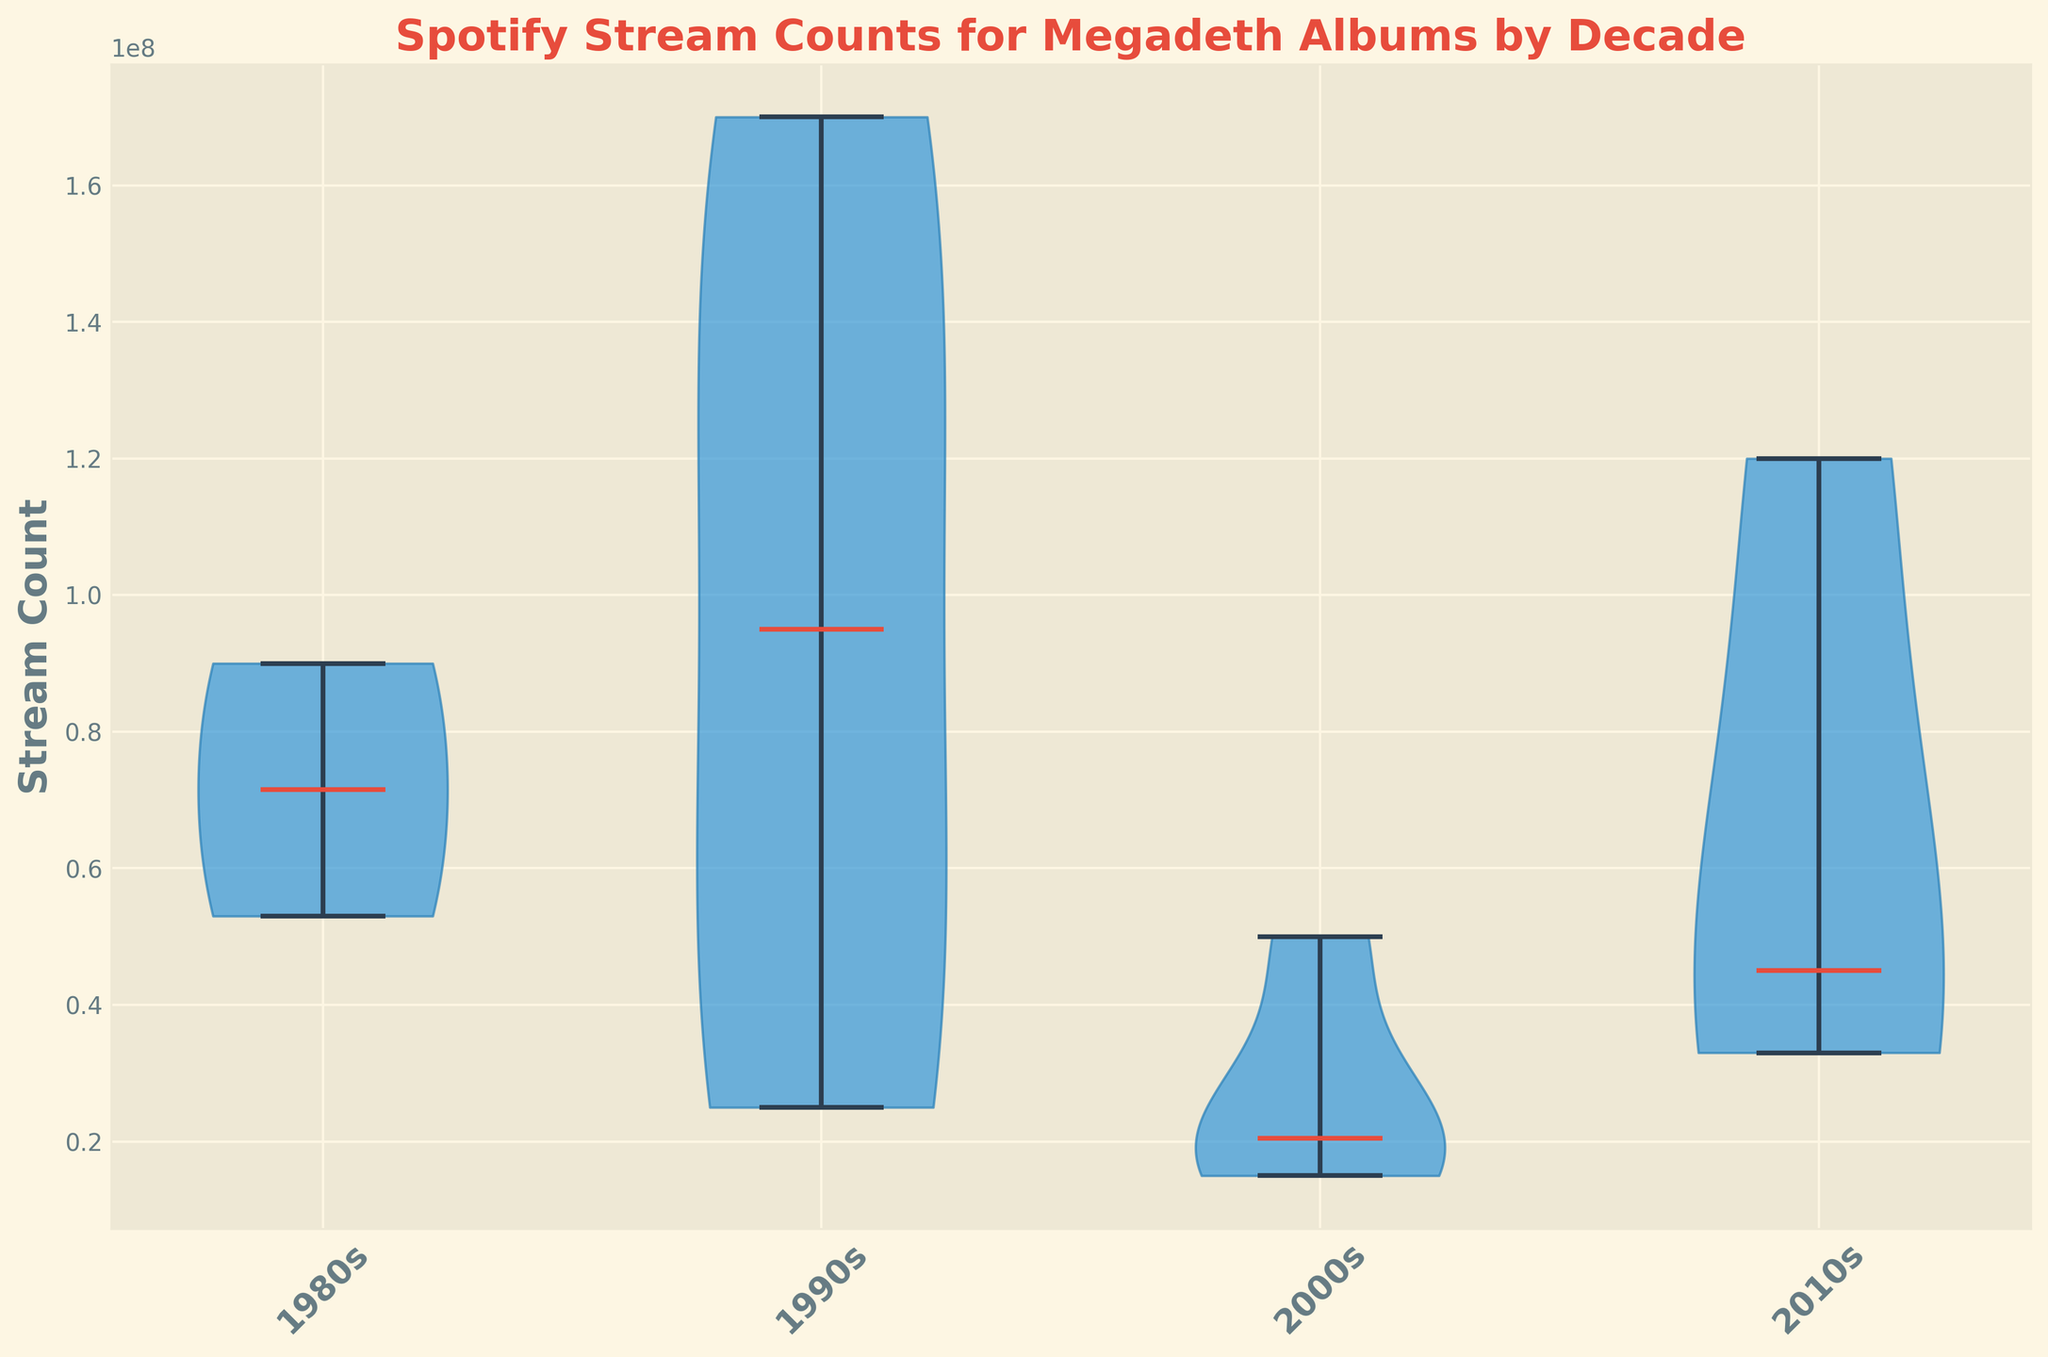What decade shows the highest median stream count? The median can be identified by looking at the central line within each violin plot. The 1990s have the highest median stream count.
Answer: 1990s Which decade has the widest distribution of stream counts? The width of the violin plots indicates the distribution of the data. The 1990s have the widest distribution, showing the most variation in stream counts.
Answer: 1990s What is the range of stream counts for the 1980s? For the range, identify the minimum and maximum values from the ends of the violin plot. The range for the 1980s is from roughly 53 million to 90 million streams.
Answer: 53 million to 90 million Which decade has the smallest spread in stream counts? The spread is indicated by the width and range of each violin plot. The 2010s show the smallest spread in stream counts.
Answer: 2010s Compare the median stream count of the 2000s to the 2010s. The median is the central line. For the 2000s, it appears roughly at 23 million, and for the 2010s, it is around 45 million.
Answer: 2010s > 2000s In which decade does the album with the highest number of streams appear? The album with the highest stream count will be at the extreme high end of any violin plot. The 1990s have the highest number of streams with an album reaching around 170 million streams.
Answer: 1990s Calculate the sum of the median stream counts for all decades. Add the medians from each decade: 1980s (~71.5m), 1990s (~95m), 2000s (~23m), 2010s (~45m). 71.5 + 95 + 23 + 45 = 234.5 million streams.
Answer: 234.5 million streams Which decade has more consistent stream counts in terms of interquartile range (IQR), the 1980s or the 2010s? Look for the shorter width within the middle half (thickest part of the violin plot). The 2010s appear more consistent with a smaller IQR.
Answer: 2010s 